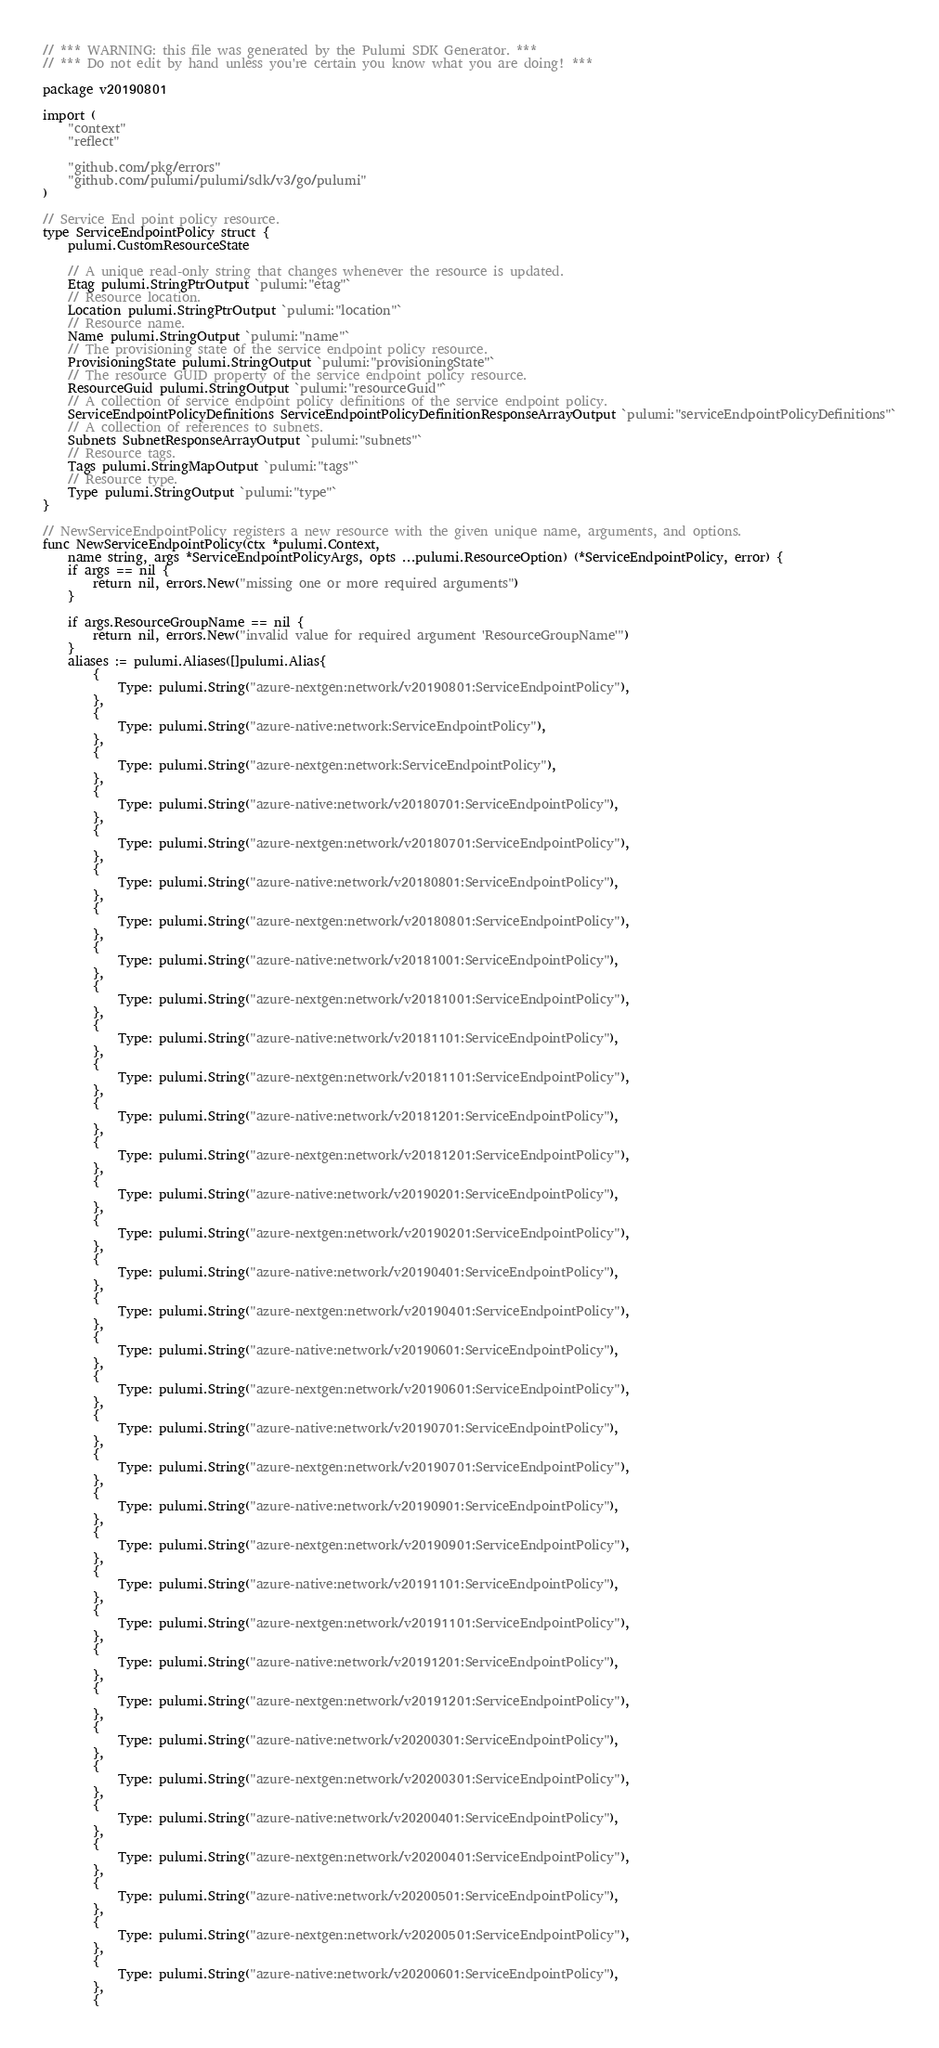<code> <loc_0><loc_0><loc_500><loc_500><_Go_>// *** WARNING: this file was generated by the Pulumi SDK Generator. ***
// *** Do not edit by hand unless you're certain you know what you are doing! ***

package v20190801

import (
	"context"
	"reflect"

	"github.com/pkg/errors"
	"github.com/pulumi/pulumi/sdk/v3/go/pulumi"
)

// Service End point policy resource.
type ServiceEndpointPolicy struct {
	pulumi.CustomResourceState

	// A unique read-only string that changes whenever the resource is updated.
	Etag pulumi.StringPtrOutput `pulumi:"etag"`
	// Resource location.
	Location pulumi.StringPtrOutput `pulumi:"location"`
	// Resource name.
	Name pulumi.StringOutput `pulumi:"name"`
	// The provisioning state of the service endpoint policy resource.
	ProvisioningState pulumi.StringOutput `pulumi:"provisioningState"`
	// The resource GUID property of the service endpoint policy resource.
	ResourceGuid pulumi.StringOutput `pulumi:"resourceGuid"`
	// A collection of service endpoint policy definitions of the service endpoint policy.
	ServiceEndpointPolicyDefinitions ServiceEndpointPolicyDefinitionResponseArrayOutput `pulumi:"serviceEndpointPolicyDefinitions"`
	// A collection of references to subnets.
	Subnets SubnetResponseArrayOutput `pulumi:"subnets"`
	// Resource tags.
	Tags pulumi.StringMapOutput `pulumi:"tags"`
	// Resource type.
	Type pulumi.StringOutput `pulumi:"type"`
}

// NewServiceEndpointPolicy registers a new resource with the given unique name, arguments, and options.
func NewServiceEndpointPolicy(ctx *pulumi.Context,
	name string, args *ServiceEndpointPolicyArgs, opts ...pulumi.ResourceOption) (*ServiceEndpointPolicy, error) {
	if args == nil {
		return nil, errors.New("missing one or more required arguments")
	}

	if args.ResourceGroupName == nil {
		return nil, errors.New("invalid value for required argument 'ResourceGroupName'")
	}
	aliases := pulumi.Aliases([]pulumi.Alias{
		{
			Type: pulumi.String("azure-nextgen:network/v20190801:ServiceEndpointPolicy"),
		},
		{
			Type: pulumi.String("azure-native:network:ServiceEndpointPolicy"),
		},
		{
			Type: pulumi.String("azure-nextgen:network:ServiceEndpointPolicy"),
		},
		{
			Type: pulumi.String("azure-native:network/v20180701:ServiceEndpointPolicy"),
		},
		{
			Type: pulumi.String("azure-nextgen:network/v20180701:ServiceEndpointPolicy"),
		},
		{
			Type: pulumi.String("azure-native:network/v20180801:ServiceEndpointPolicy"),
		},
		{
			Type: pulumi.String("azure-nextgen:network/v20180801:ServiceEndpointPolicy"),
		},
		{
			Type: pulumi.String("azure-native:network/v20181001:ServiceEndpointPolicy"),
		},
		{
			Type: pulumi.String("azure-nextgen:network/v20181001:ServiceEndpointPolicy"),
		},
		{
			Type: pulumi.String("azure-native:network/v20181101:ServiceEndpointPolicy"),
		},
		{
			Type: pulumi.String("azure-nextgen:network/v20181101:ServiceEndpointPolicy"),
		},
		{
			Type: pulumi.String("azure-native:network/v20181201:ServiceEndpointPolicy"),
		},
		{
			Type: pulumi.String("azure-nextgen:network/v20181201:ServiceEndpointPolicy"),
		},
		{
			Type: pulumi.String("azure-native:network/v20190201:ServiceEndpointPolicy"),
		},
		{
			Type: pulumi.String("azure-nextgen:network/v20190201:ServiceEndpointPolicy"),
		},
		{
			Type: pulumi.String("azure-native:network/v20190401:ServiceEndpointPolicy"),
		},
		{
			Type: pulumi.String("azure-nextgen:network/v20190401:ServiceEndpointPolicy"),
		},
		{
			Type: pulumi.String("azure-native:network/v20190601:ServiceEndpointPolicy"),
		},
		{
			Type: pulumi.String("azure-nextgen:network/v20190601:ServiceEndpointPolicy"),
		},
		{
			Type: pulumi.String("azure-native:network/v20190701:ServiceEndpointPolicy"),
		},
		{
			Type: pulumi.String("azure-nextgen:network/v20190701:ServiceEndpointPolicy"),
		},
		{
			Type: pulumi.String("azure-native:network/v20190901:ServiceEndpointPolicy"),
		},
		{
			Type: pulumi.String("azure-nextgen:network/v20190901:ServiceEndpointPolicy"),
		},
		{
			Type: pulumi.String("azure-native:network/v20191101:ServiceEndpointPolicy"),
		},
		{
			Type: pulumi.String("azure-nextgen:network/v20191101:ServiceEndpointPolicy"),
		},
		{
			Type: pulumi.String("azure-native:network/v20191201:ServiceEndpointPolicy"),
		},
		{
			Type: pulumi.String("azure-nextgen:network/v20191201:ServiceEndpointPolicy"),
		},
		{
			Type: pulumi.String("azure-native:network/v20200301:ServiceEndpointPolicy"),
		},
		{
			Type: pulumi.String("azure-nextgen:network/v20200301:ServiceEndpointPolicy"),
		},
		{
			Type: pulumi.String("azure-native:network/v20200401:ServiceEndpointPolicy"),
		},
		{
			Type: pulumi.String("azure-nextgen:network/v20200401:ServiceEndpointPolicy"),
		},
		{
			Type: pulumi.String("azure-native:network/v20200501:ServiceEndpointPolicy"),
		},
		{
			Type: pulumi.String("azure-nextgen:network/v20200501:ServiceEndpointPolicy"),
		},
		{
			Type: pulumi.String("azure-native:network/v20200601:ServiceEndpointPolicy"),
		},
		{</code> 